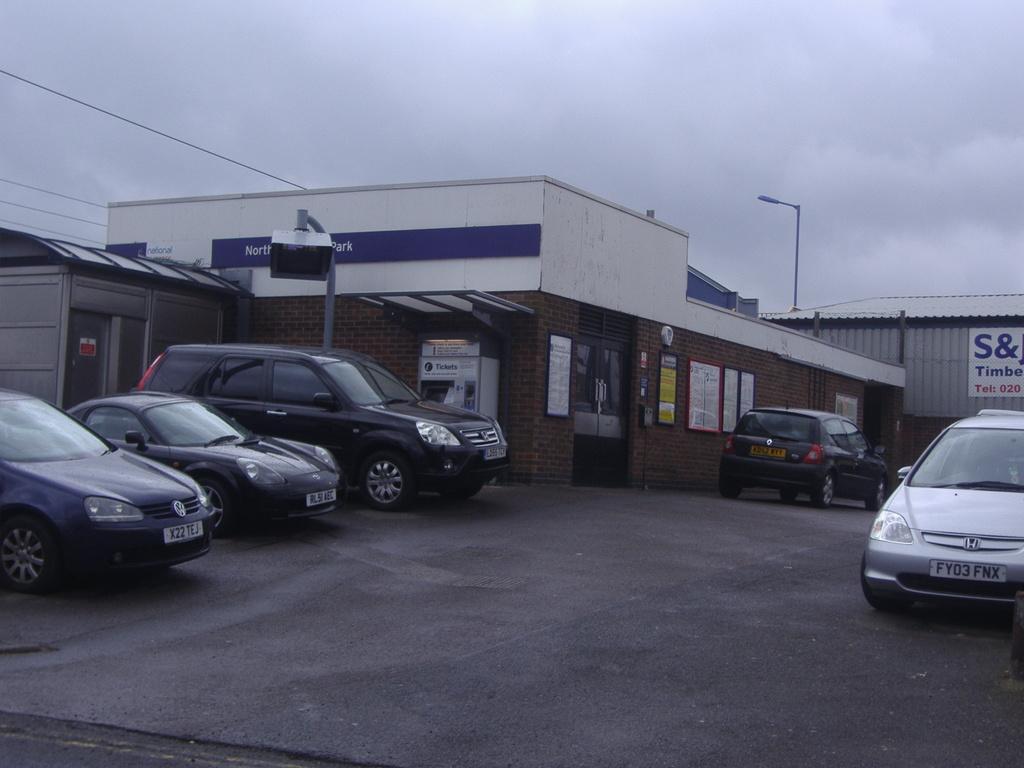In one or two sentences, can you explain what this image depicts? In this image we can see motor vehicles on the road, buildings, street pole, street light, shed, advertisement boards, cables and sky with clouds. 